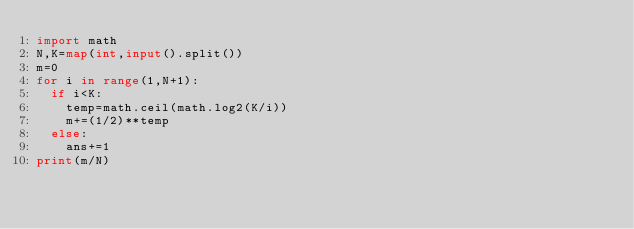<code> <loc_0><loc_0><loc_500><loc_500><_Python_>import math
N,K=map(int,input().split())
m=0
for i in range(1,N+1):
  if i<K:
    temp=math.ceil(math.log2(K/i))
    m+=(1/2)**temp
  else:
    ans+=1
print(m/N)</code> 